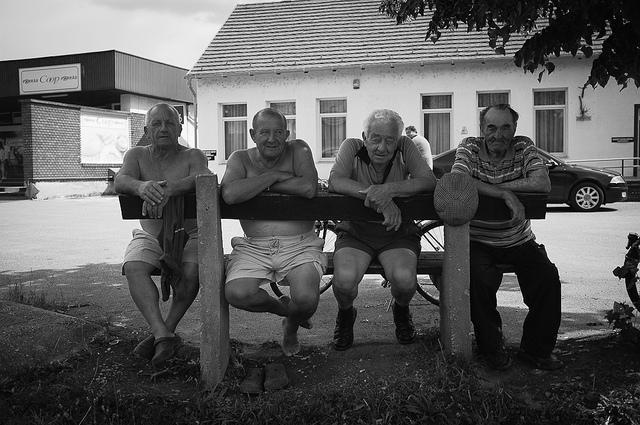How many people are there?
Give a very brief answer. 4. How many persons are wear hats in this picture?
Give a very brief answer. 0. How many men are shown?
Give a very brief answer. 4. How many people are posing for a photo?
Give a very brief answer. 4. How many people are in the picture?
Give a very brief answer. 4. How many people can be seen?
Give a very brief answer. 4. 